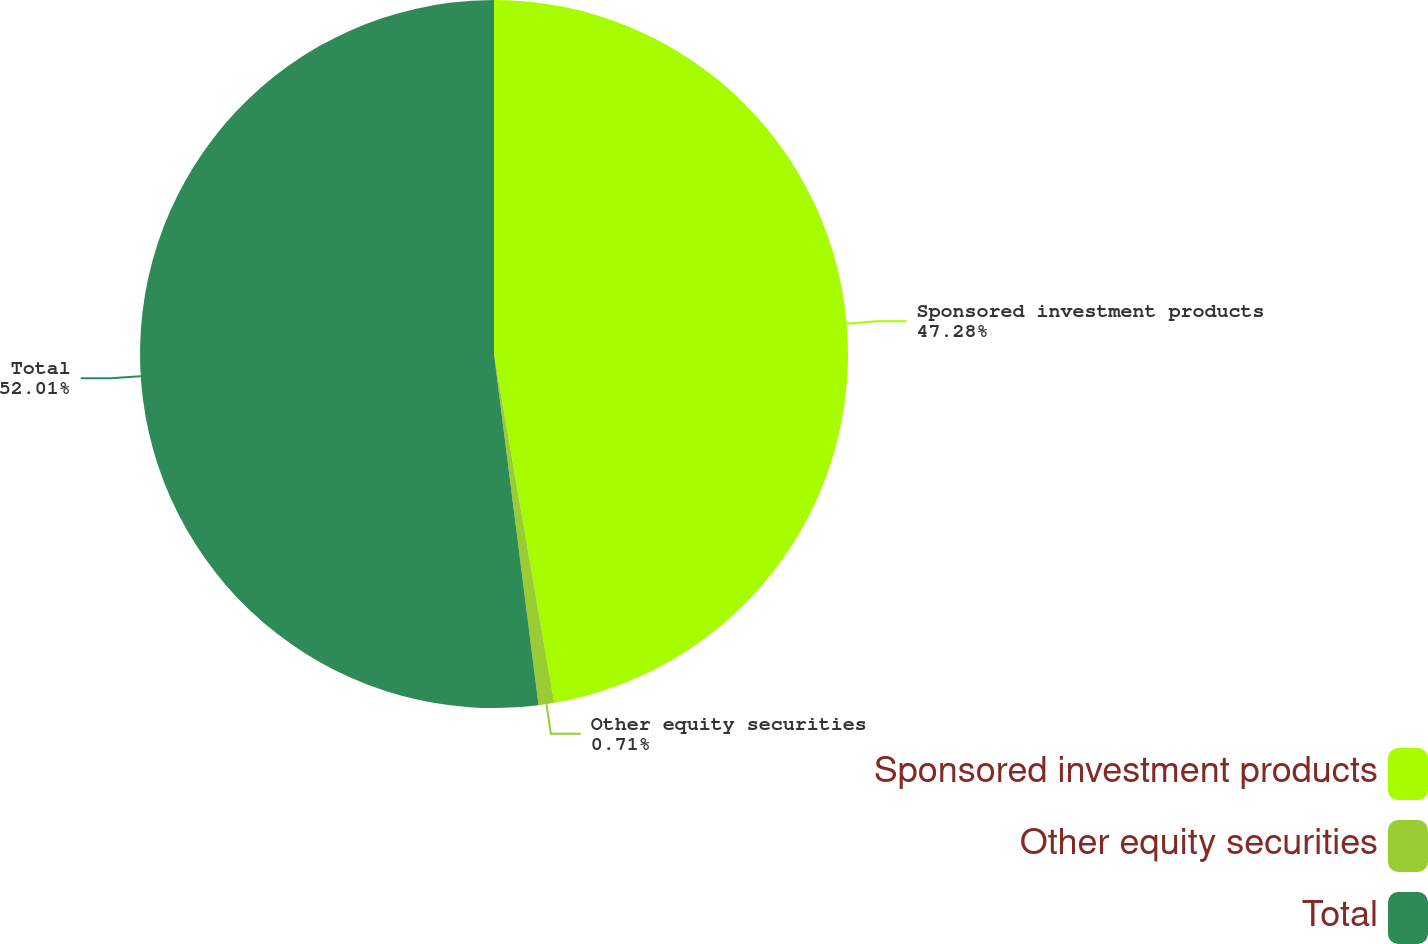Convert chart to OTSL. <chart><loc_0><loc_0><loc_500><loc_500><pie_chart><fcel>Sponsored investment products<fcel>Other equity securities<fcel>Total<nl><fcel>47.28%<fcel>0.71%<fcel>52.01%<nl></chart> 